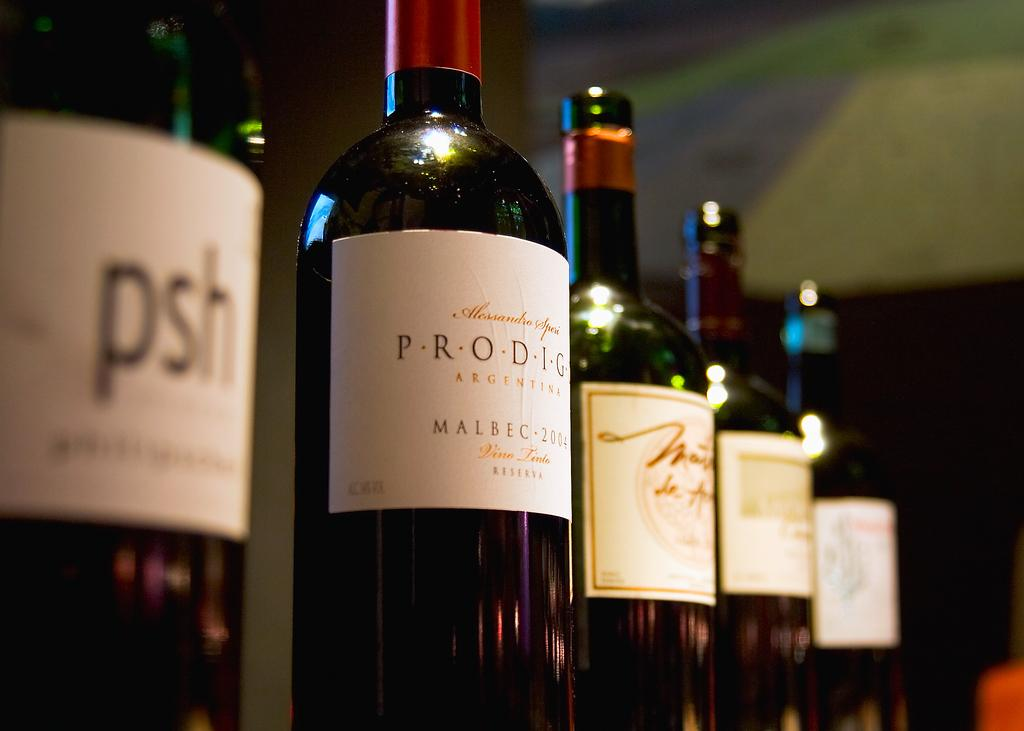Provide a one-sentence caption for the provided image. A bottle of Prodigy Malbec is one in a line of wine bottles. 